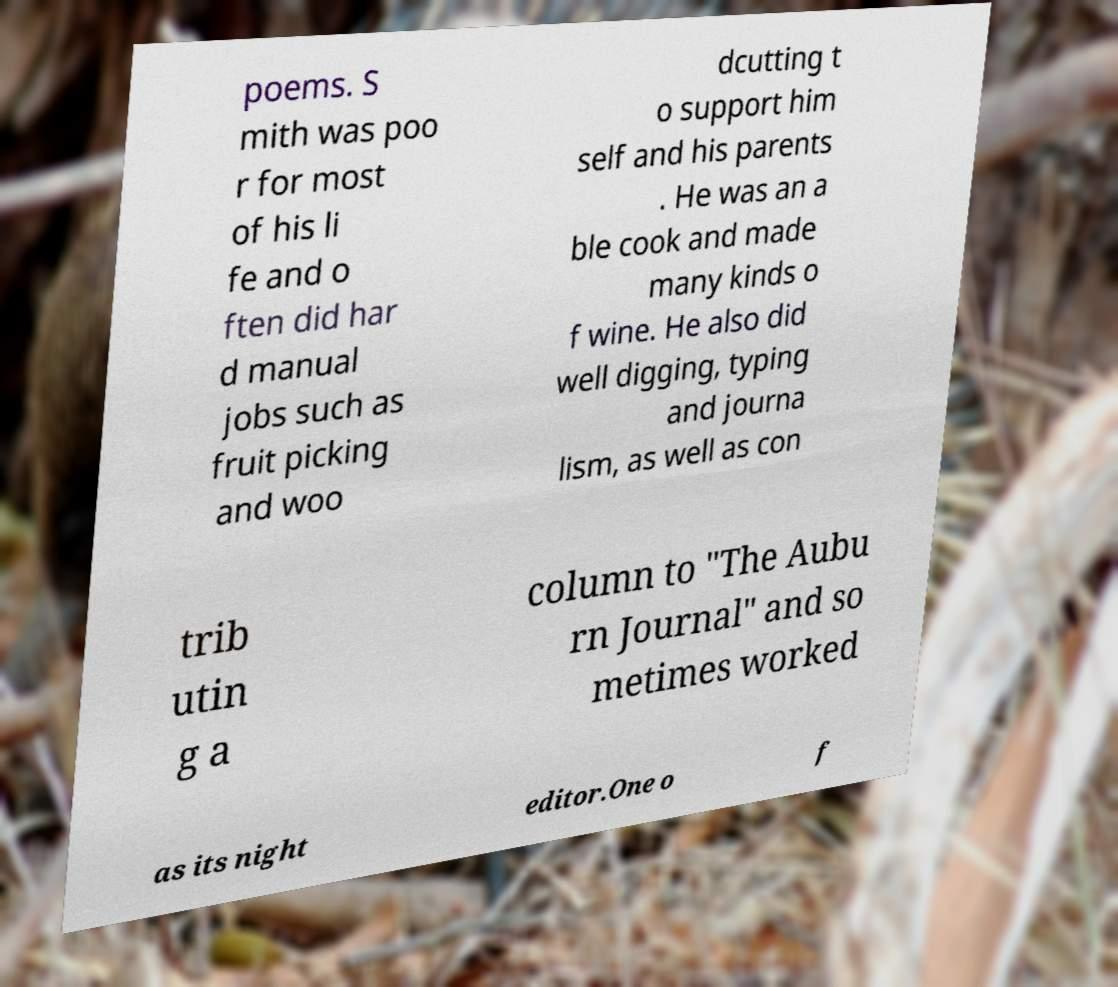For documentation purposes, I need the text within this image transcribed. Could you provide that? poems. S mith was poo r for most of his li fe and o ften did har d manual jobs such as fruit picking and woo dcutting t o support him self and his parents . He was an a ble cook and made many kinds o f wine. He also did well digging, typing and journa lism, as well as con trib utin g a column to "The Aubu rn Journal" and so metimes worked as its night editor.One o f 